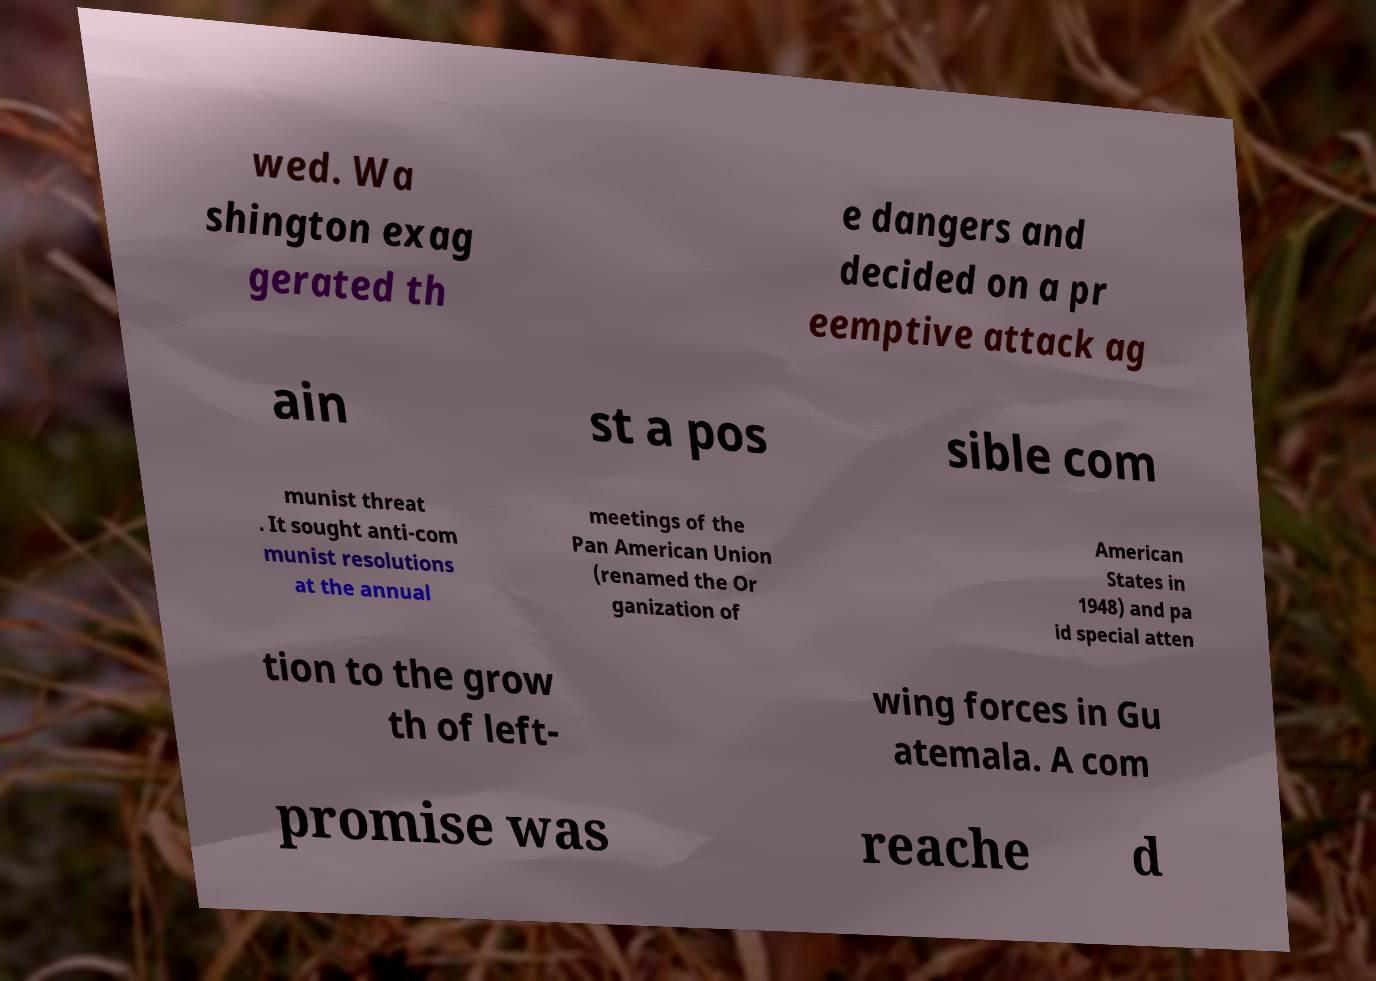For documentation purposes, I need the text within this image transcribed. Could you provide that? wed. Wa shington exag gerated th e dangers and decided on a pr eemptive attack ag ain st a pos sible com munist threat . It sought anti-com munist resolutions at the annual meetings of the Pan American Union (renamed the Or ganization of American States in 1948) and pa id special atten tion to the grow th of left- wing forces in Gu atemala. A com promise was reache d 